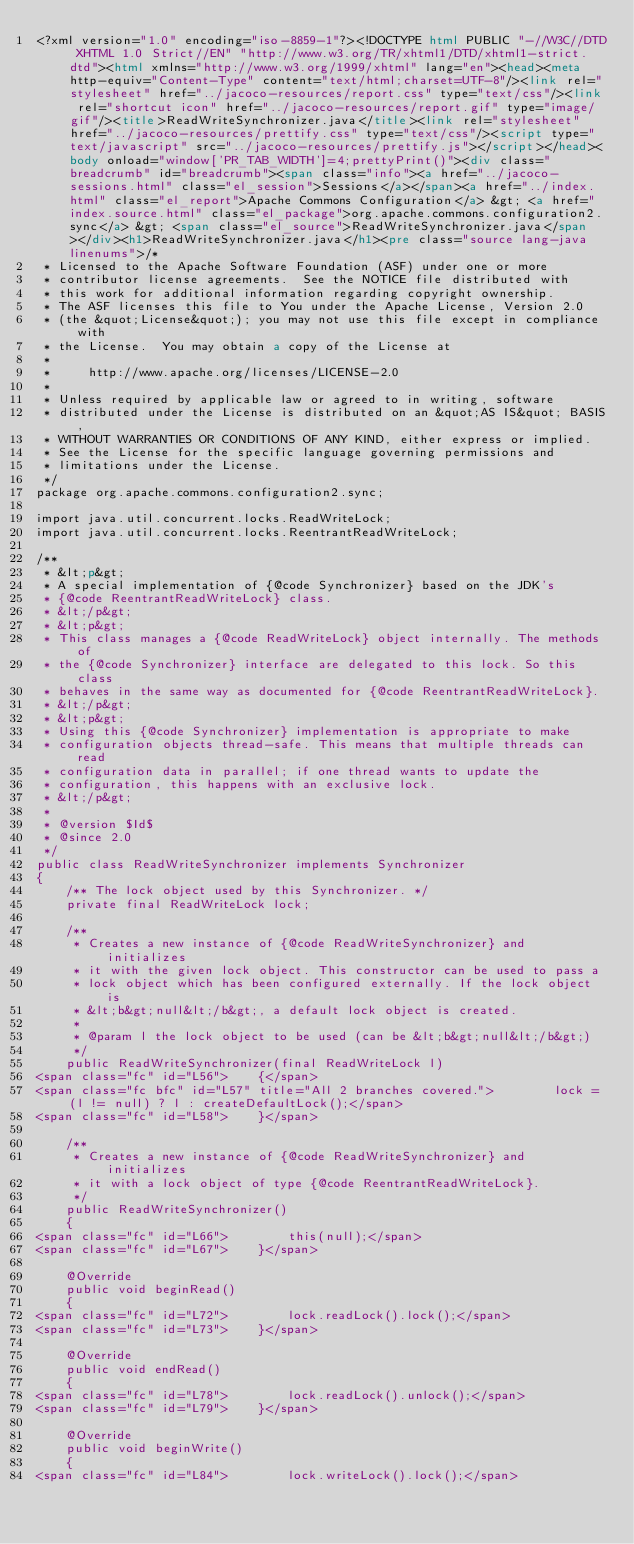Convert code to text. <code><loc_0><loc_0><loc_500><loc_500><_HTML_><?xml version="1.0" encoding="iso-8859-1"?><!DOCTYPE html PUBLIC "-//W3C//DTD XHTML 1.0 Strict//EN" "http://www.w3.org/TR/xhtml1/DTD/xhtml1-strict.dtd"><html xmlns="http://www.w3.org/1999/xhtml" lang="en"><head><meta http-equiv="Content-Type" content="text/html;charset=UTF-8"/><link rel="stylesheet" href="../jacoco-resources/report.css" type="text/css"/><link rel="shortcut icon" href="../jacoco-resources/report.gif" type="image/gif"/><title>ReadWriteSynchronizer.java</title><link rel="stylesheet" href="../jacoco-resources/prettify.css" type="text/css"/><script type="text/javascript" src="../jacoco-resources/prettify.js"></script></head><body onload="window['PR_TAB_WIDTH']=4;prettyPrint()"><div class="breadcrumb" id="breadcrumb"><span class="info"><a href="../jacoco-sessions.html" class="el_session">Sessions</a></span><a href="../index.html" class="el_report">Apache Commons Configuration</a> &gt; <a href="index.source.html" class="el_package">org.apache.commons.configuration2.sync</a> &gt; <span class="el_source">ReadWriteSynchronizer.java</span></div><h1>ReadWriteSynchronizer.java</h1><pre class="source lang-java linenums">/*
 * Licensed to the Apache Software Foundation (ASF) under one or more
 * contributor license agreements.  See the NOTICE file distributed with
 * this work for additional information regarding copyright ownership.
 * The ASF licenses this file to You under the Apache License, Version 2.0
 * (the &quot;License&quot;); you may not use this file except in compliance with
 * the License.  You may obtain a copy of the License at
 *
 *     http://www.apache.org/licenses/LICENSE-2.0
 *
 * Unless required by applicable law or agreed to in writing, software
 * distributed under the License is distributed on an &quot;AS IS&quot; BASIS,
 * WITHOUT WARRANTIES OR CONDITIONS OF ANY KIND, either express or implied.
 * See the License for the specific language governing permissions and
 * limitations under the License.
 */
package org.apache.commons.configuration2.sync;

import java.util.concurrent.locks.ReadWriteLock;
import java.util.concurrent.locks.ReentrantReadWriteLock;

/**
 * &lt;p&gt;
 * A special implementation of {@code Synchronizer} based on the JDK's
 * {@code ReentrantReadWriteLock} class.
 * &lt;/p&gt;
 * &lt;p&gt;
 * This class manages a {@code ReadWriteLock} object internally. The methods of
 * the {@code Synchronizer} interface are delegated to this lock. So this class
 * behaves in the same way as documented for {@code ReentrantReadWriteLock}.
 * &lt;/p&gt;
 * &lt;p&gt;
 * Using this {@code Synchronizer} implementation is appropriate to make
 * configuration objects thread-safe. This means that multiple threads can read
 * configuration data in parallel; if one thread wants to update the
 * configuration, this happens with an exclusive lock.
 * &lt;/p&gt;
 *
 * @version $Id$
 * @since 2.0
 */
public class ReadWriteSynchronizer implements Synchronizer
{
    /** The lock object used by this Synchronizer. */
    private final ReadWriteLock lock;

    /**
     * Creates a new instance of {@code ReadWriteSynchronizer} and initializes
     * it with the given lock object. This constructor can be used to pass a
     * lock object which has been configured externally. If the lock object is
     * &lt;b&gt;null&lt;/b&gt;, a default lock object is created.
     *
     * @param l the lock object to be used (can be &lt;b&gt;null&lt;/b&gt;)
     */
    public ReadWriteSynchronizer(final ReadWriteLock l)
<span class="fc" id="L56">    {</span>
<span class="fc bfc" id="L57" title="All 2 branches covered.">        lock = (l != null) ? l : createDefaultLock();</span>
<span class="fc" id="L58">    }</span>

    /**
     * Creates a new instance of {@code ReadWriteSynchronizer} and initializes
     * it with a lock object of type {@code ReentrantReadWriteLock}.
     */
    public ReadWriteSynchronizer()
    {
<span class="fc" id="L66">        this(null);</span>
<span class="fc" id="L67">    }</span>

    @Override
    public void beginRead()
    {
<span class="fc" id="L72">        lock.readLock().lock();</span>
<span class="fc" id="L73">    }</span>

    @Override
    public void endRead()
    {
<span class="fc" id="L78">        lock.readLock().unlock();</span>
<span class="fc" id="L79">    }</span>

    @Override
    public void beginWrite()
    {
<span class="fc" id="L84">        lock.writeLock().lock();</span></code> 